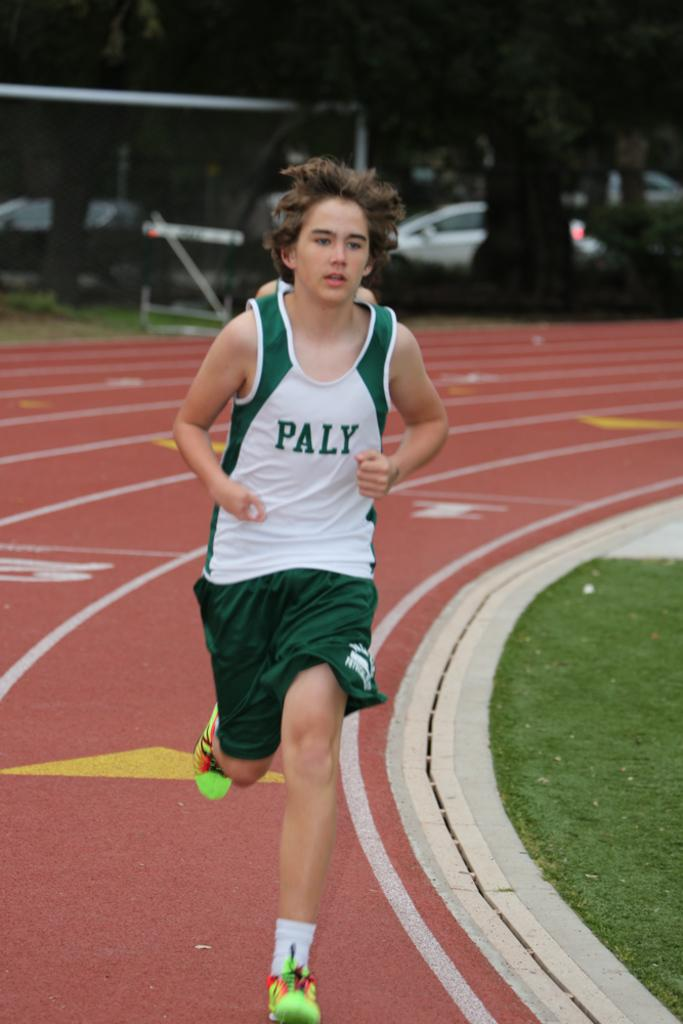Provide a one-sentence caption for the provided image. A male track runner running on the track wearing a green and white tank shirt with the word Paly across the front and green shorts. 